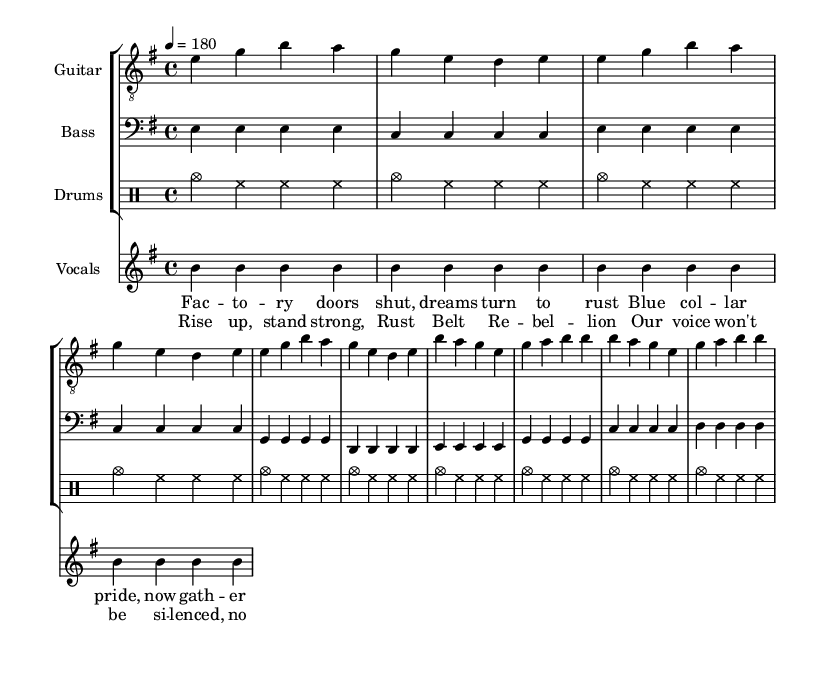What is the key signature of this music? The key signature is E minor, which includes one sharp (F#). It can be identified by looking at the key signature symbol at the beginning of the staff.
Answer: E minor What is the time signature of this music? The time signature is 4/4, indicated at the beginning of the sheet music with a '4' over a '4'. This means there are 4 beats in each measure, and the quarter note gets one beat.
Answer: 4/4 What is the tempo marking for this piece? The tempo marking indicates 180 beats per minute, shown as "4 = 180." This tells musicians the speed at which the piece should be played.
Answer: 180 How many measures are there in the chorus section? The chorus section consists of 4 measures, which can be identified by counting the measures indicated in the notation. Each group of notes is separated by vertical lines indicating the end of each measure.
Answer: 4 What mood does the song convey based on the lyrics? The lyrics suggest a tone of resistance and defiance, as they focus on themes of strength and rebellion against oppression. Phrases like "Rise up, stand strong" indicate an empowering message relevant to working-class struggles.
Answer: Defiance What kind of social issues are addressed in the lyrics? The lyrics address issues such as economic decline and worker's rights, reflecting the struggles of the working class in areas like the Rust Belt, highlighting a sense of disillusionment and pride. This showcases the connection between the song's content and its political context.
Answer: Worker’s rights What is the rhythmic pattern used in the drum part? The drum part predominantly features a simple and driving rhythm, characterized by a pattern of cymbals and hi-hats in steady eighth notes, which is typical in punk music to maintain energy and momentum throughout the song.
Answer: Driving rhythm 